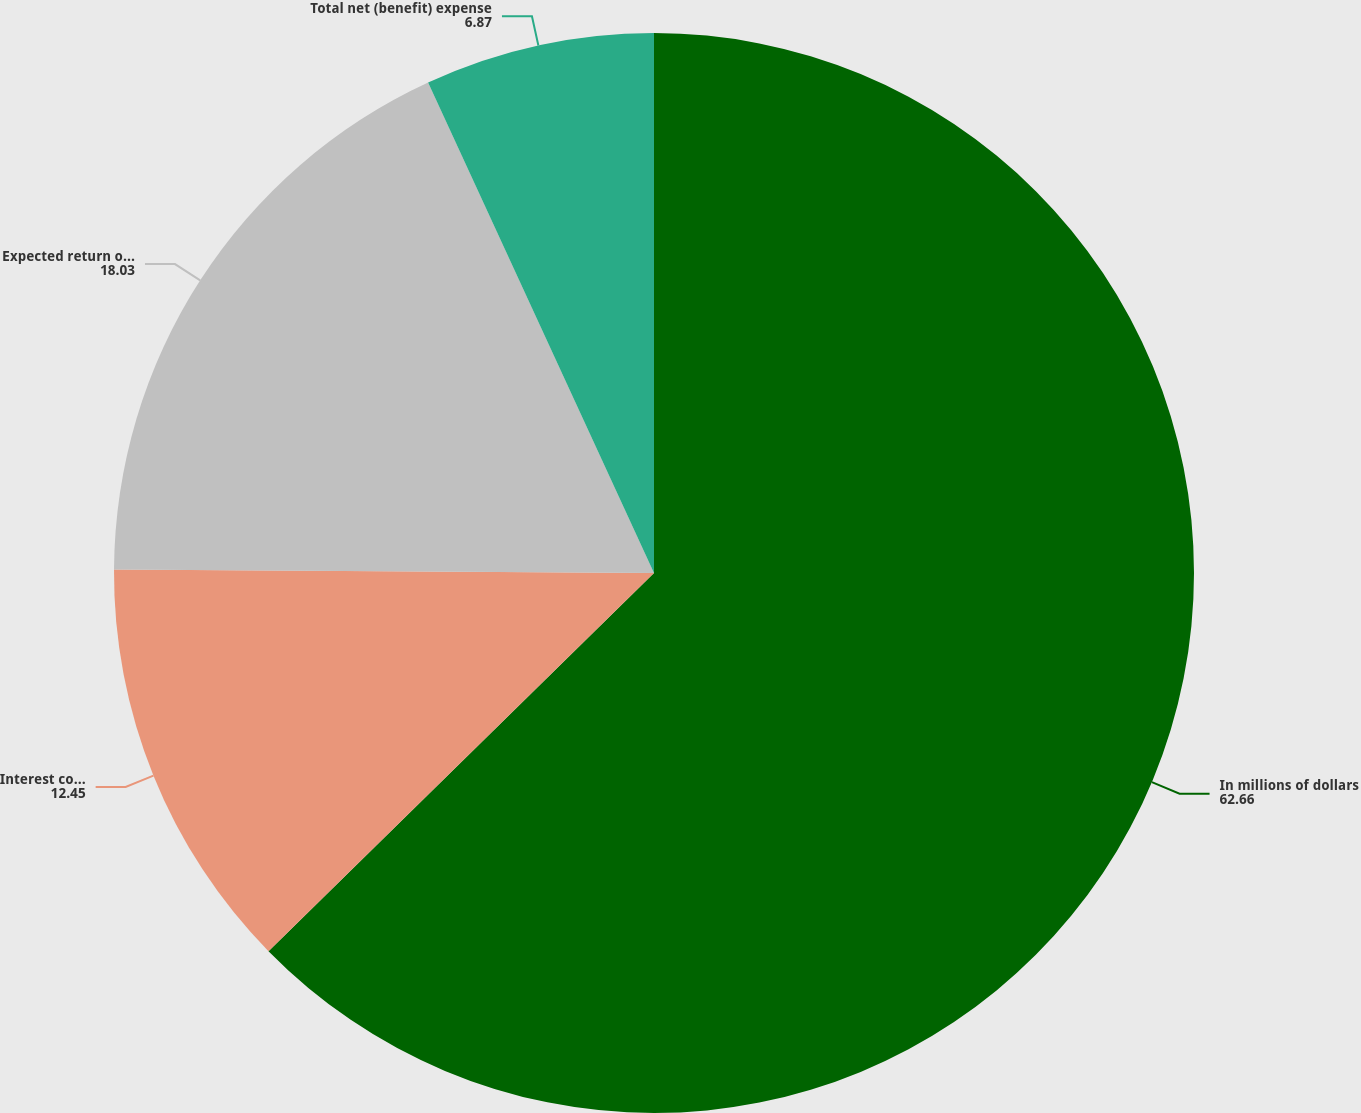<chart> <loc_0><loc_0><loc_500><loc_500><pie_chart><fcel>In millions of dollars<fcel>Interest cost on benefit<fcel>Expected return on plan assets<fcel>Total net (benefit) expense<nl><fcel>62.66%<fcel>12.45%<fcel>18.03%<fcel>6.87%<nl></chart> 